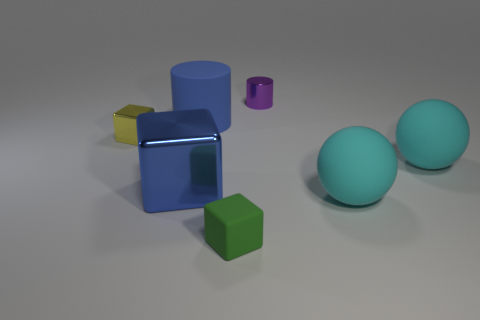What shape is the big object that is the same color as the large cube?
Give a very brief answer. Cylinder. How many small metal objects are in front of the tiny object that is behind the yellow thing?
Provide a short and direct response. 1. Is the tiny purple cylinder made of the same material as the big blue cylinder?
Provide a short and direct response. No. What number of tiny blocks are on the left side of the rubber sphere that is right of the large thing that is in front of the blue block?
Make the answer very short. 2. There is a small cube to the left of the tiny green cube; what is its color?
Your answer should be very brief. Yellow. The big cyan object that is behind the blue object in front of the large rubber cylinder is what shape?
Your answer should be very brief. Sphere. Does the large shiny block have the same color as the small matte cube?
Give a very brief answer. No. What number of balls are either blue shiny things or small yellow metal objects?
Your answer should be very brief. 0. What material is the thing that is both behind the blue metallic object and to the right of the tiny cylinder?
Make the answer very short. Rubber. How many small yellow metallic objects are left of the blue rubber thing?
Offer a very short reply. 1. 